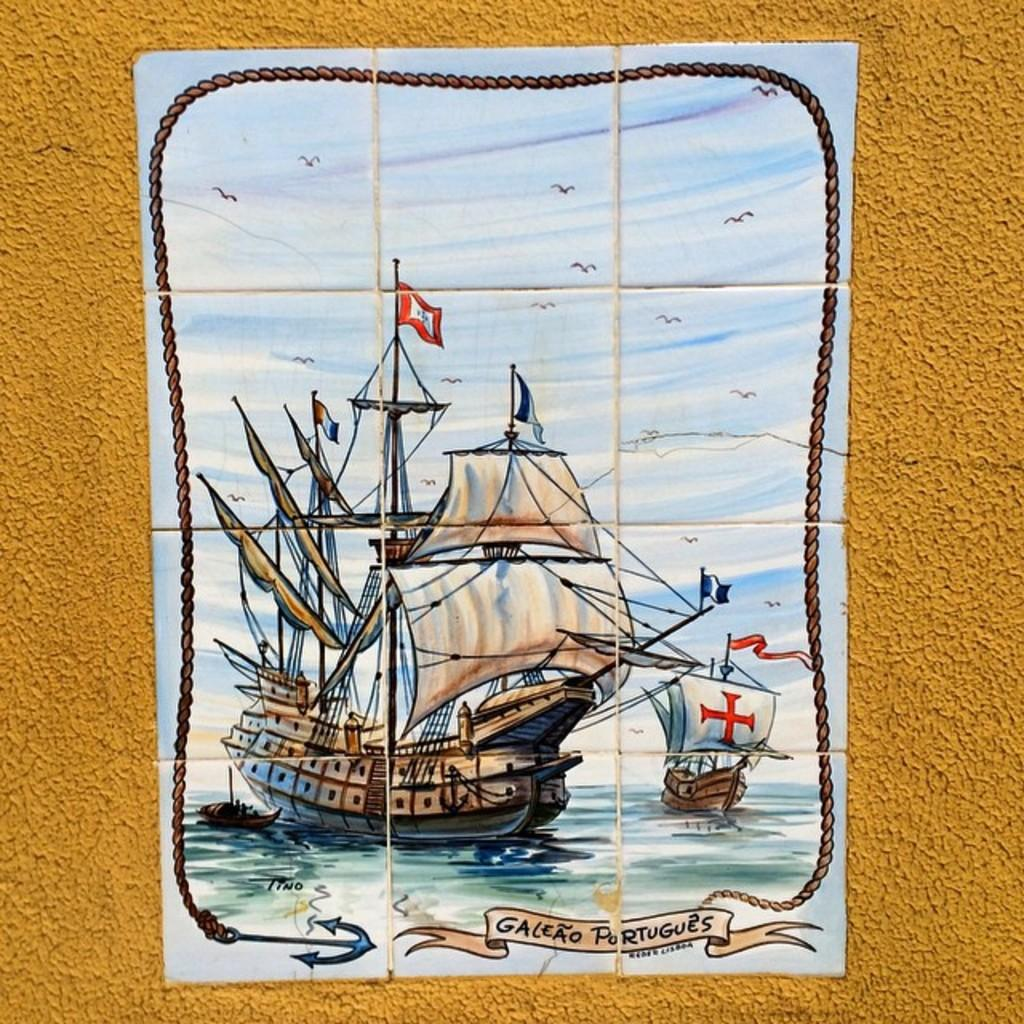<image>
Present a compact description of the photo's key features. a tile that says galeao portugues on it 